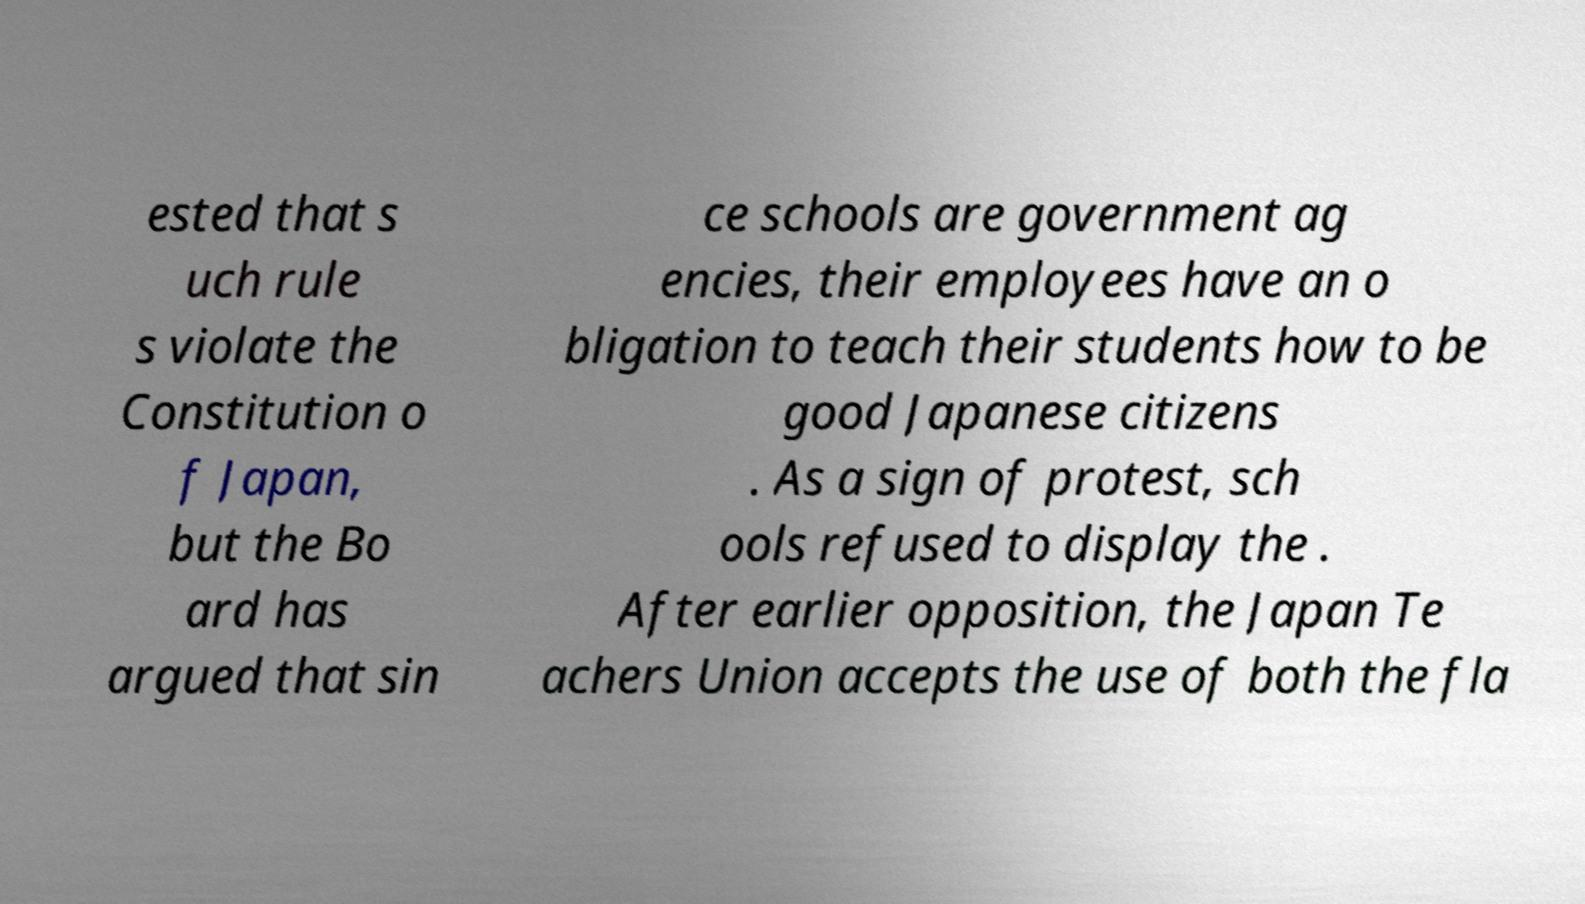I need the written content from this picture converted into text. Can you do that? ested that s uch rule s violate the Constitution o f Japan, but the Bo ard has argued that sin ce schools are government ag encies, their employees have an o bligation to teach their students how to be good Japanese citizens . As a sign of protest, sch ools refused to display the . After earlier opposition, the Japan Te achers Union accepts the use of both the fla 